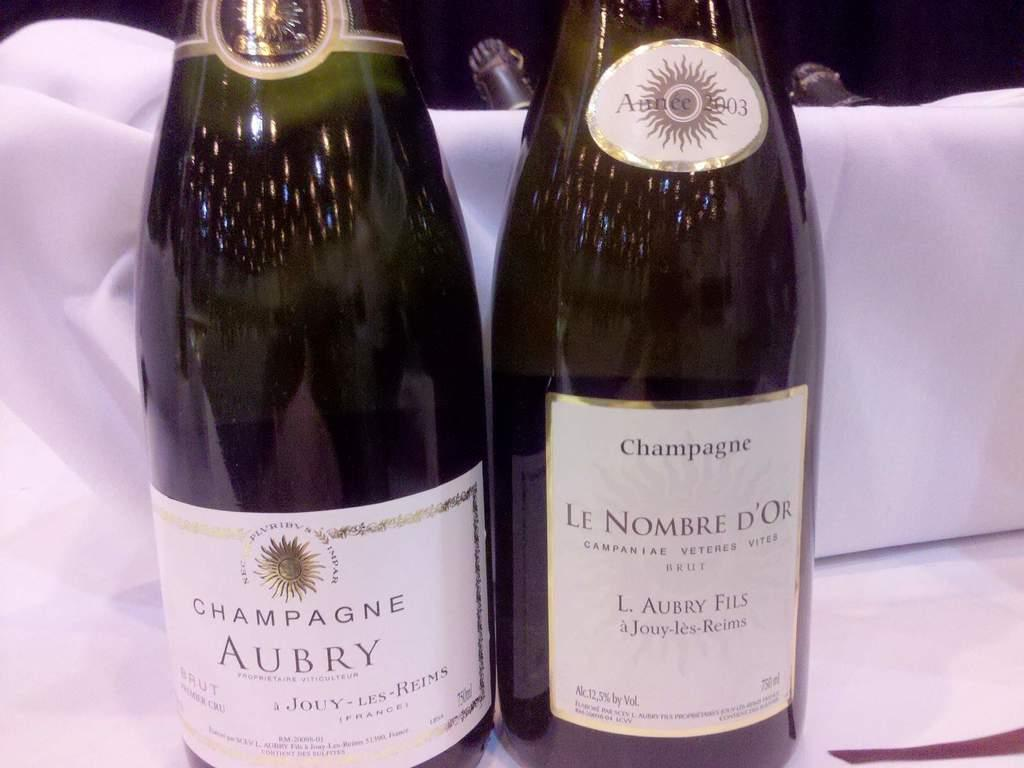<image>
Summarize the visual content of the image. A bottle of Aubry champagne is next to another bottle. 